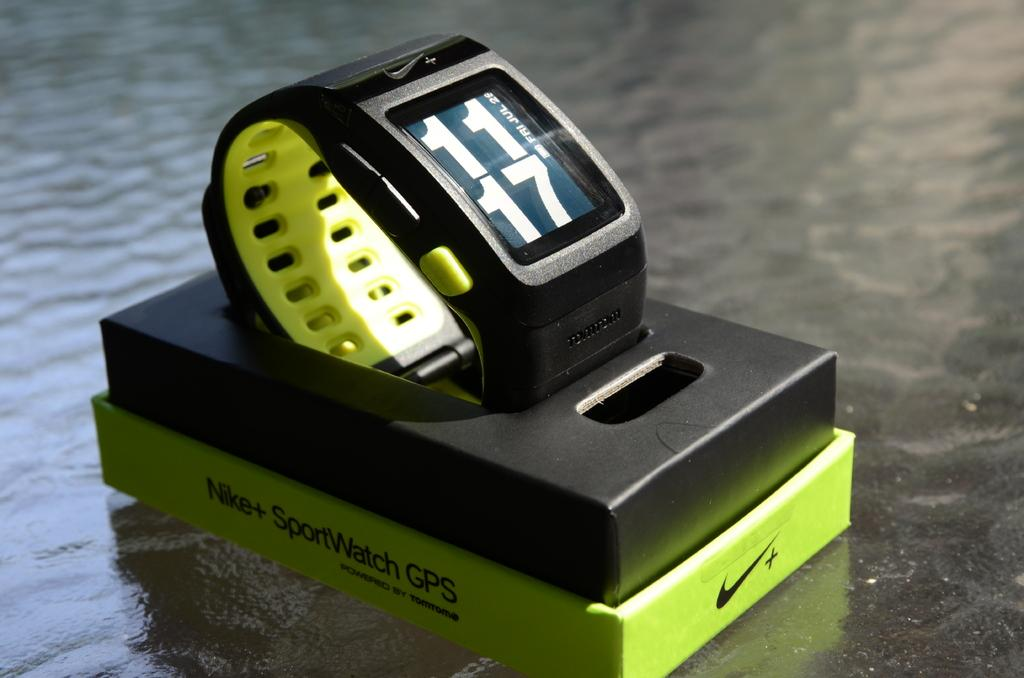<image>
Create a compact narrative representing the image presented. A green and black Nike SportWatch GPS on a glass table. 